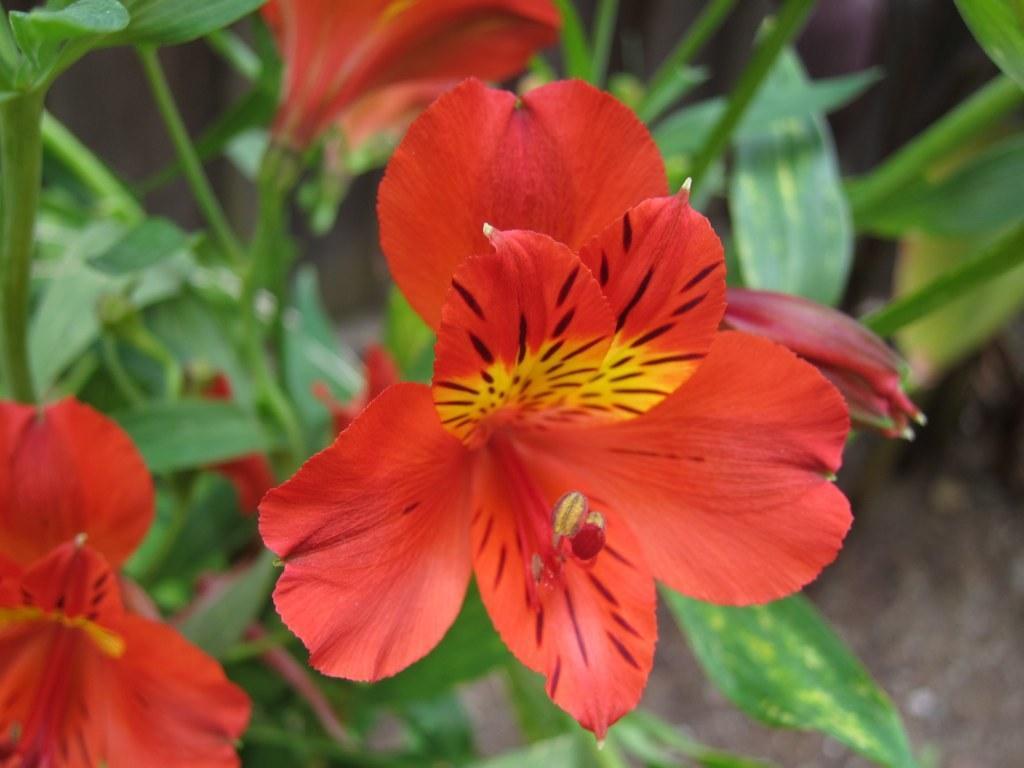Could you give a brief overview of what you see in this image? In this image, I can see the flowers and leaves. There is a blurred background. 